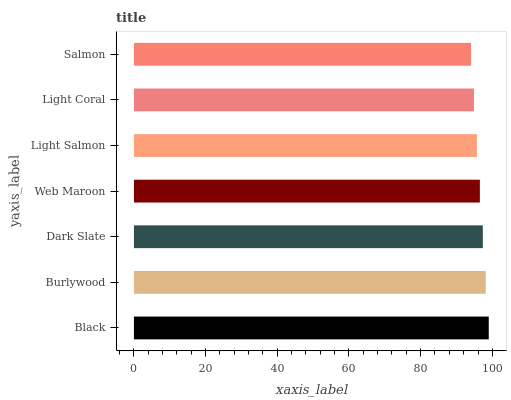Is Salmon the minimum?
Answer yes or no. Yes. Is Black the maximum?
Answer yes or no. Yes. Is Burlywood the minimum?
Answer yes or no. No. Is Burlywood the maximum?
Answer yes or no. No. Is Black greater than Burlywood?
Answer yes or no. Yes. Is Burlywood less than Black?
Answer yes or no. Yes. Is Burlywood greater than Black?
Answer yes or no. No. Is Black less than Burlywood?
Answer yes or no. No. Is Web Maroon the high median?
Answer yes or no. Yes. Is Web Maroon the low median?
Answer yes or no. Yes. Is Salmon the high median?
Answer yes or no. No. Is Black the low median?
Answer yes or no. No. 